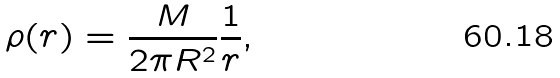<formula> <loc_0><loc_0><loc_500><loc_500>\rho ( r ) = \frac { M } { 2 \pi R ^ { 2 } } \frac { 1 } { r } ,</formula> 